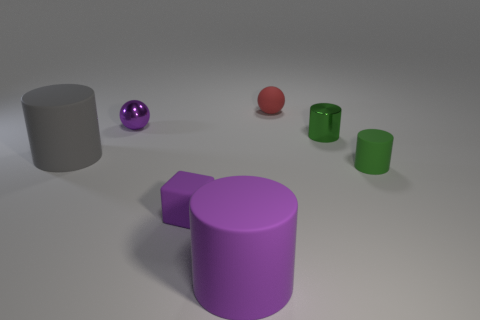How does the lighting in the scene affect the appearance of the objects? The lighting in the scene is soft and diffused, creating gentle shadows and a subtle sense of depth. It enhances the contrast between the shiny and matte surfaces; reflective objects like the shiny purple ball have prominent highlights and defined reflections, while the matte objects absorb light, minimizing reflections and appearing more even in color. The lighting condition also influences the perceived texture, with the shiny surfaces appearing slick and the matte surfaces appearing more tactile. 